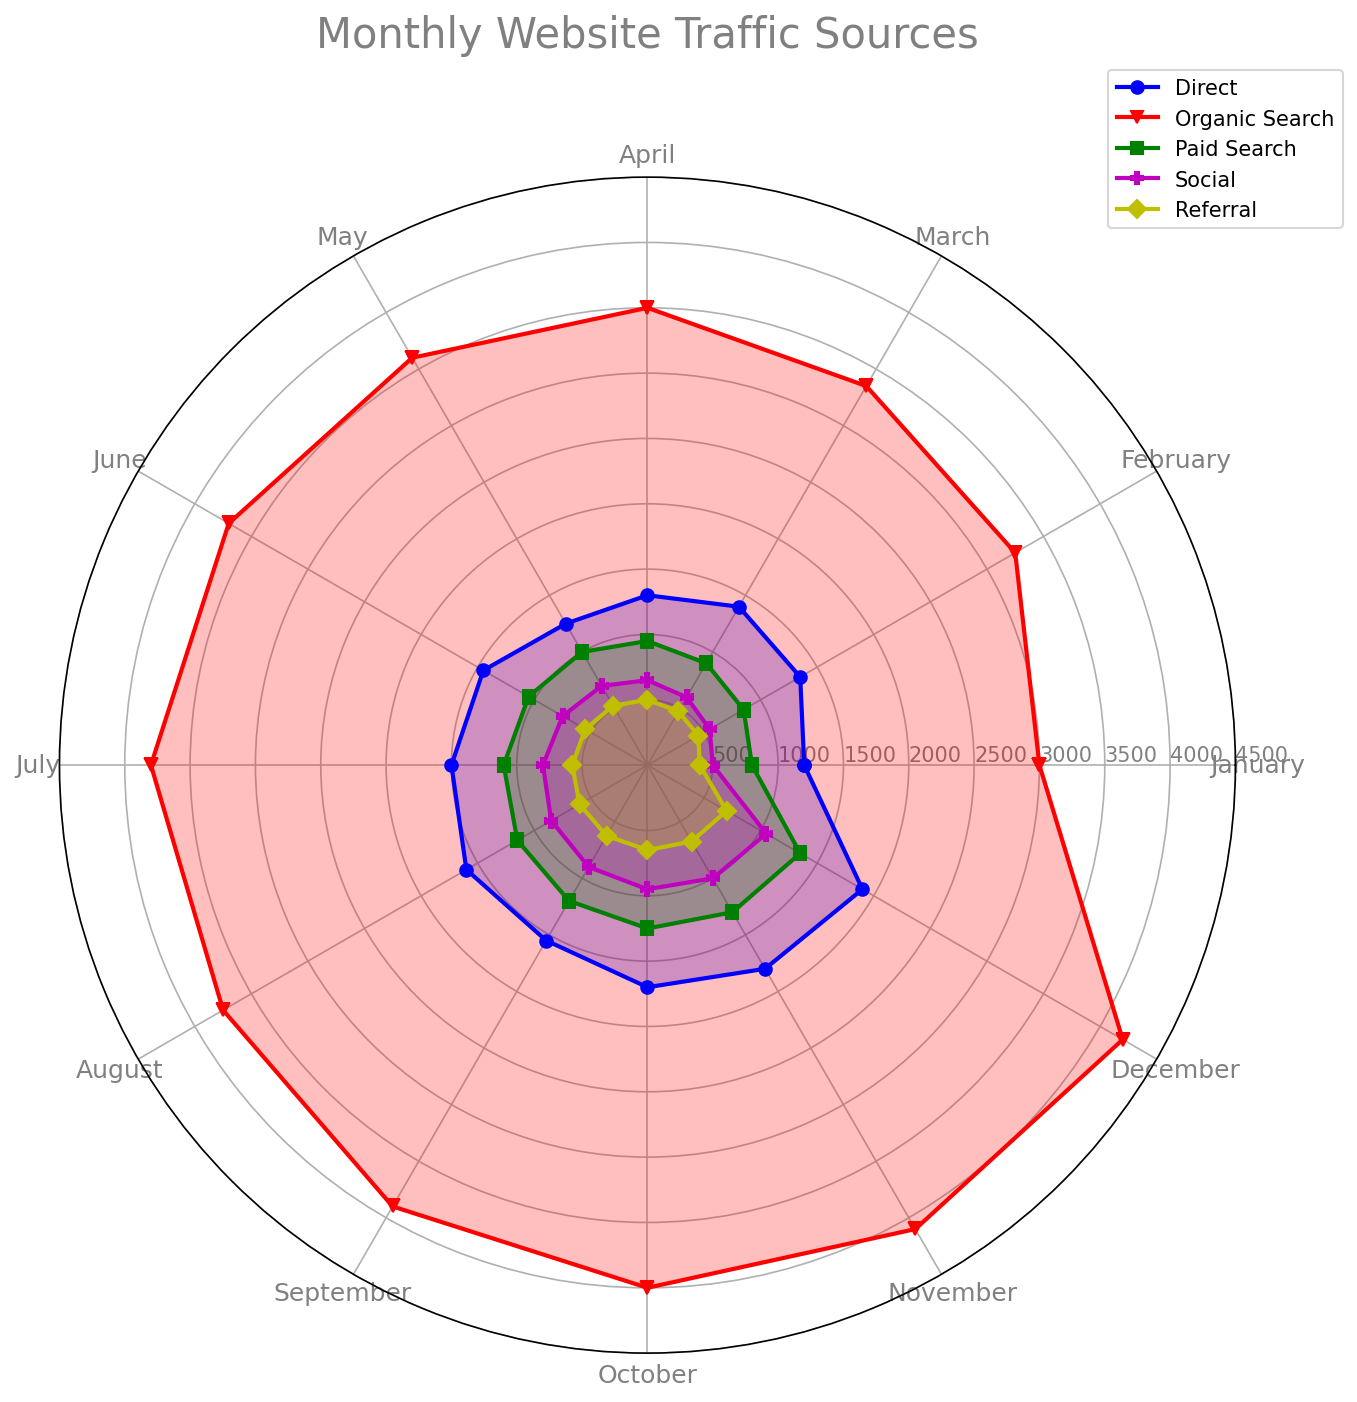what is the traffic source with the lowest overall values across months? By looking at the radar chart, we compare the plotted values for each traffic source. Referral has the smallest fill area, indicating its values are the lowest across the months.
Answer: Referral Which traffic source has the highest values in November? By checking the plotted values and their labels on the chart, Organic Search shows the highest value in November.
Answer: Organic Search what is the average monthly value of Social traffic? Add all monthly values of Social traffic and divide by 12: (500+550+600+650+700+750+800+850+900+950+1000+1050)/12 = 775
Answer: 775 How does Paid Search traffic in May compare to Direct traffic in May? In May, Paid Search traffic is 1000, while Direct traffic is 1250. Direct traffic is higher.
Answer: Direct is higher which traffic sources have an increasing trend over the months? By visually inspecting the shape of the plots for each source, Organic Search, Paid Search, Social, and Referral all show increasing trends as they move outwards through the months.
Answer: Organic Search, Paid Search, Social, Referral What is the difference between the highest and lowest traffic sources in December? In December, Organic Search has the highest value (4200), and Referral has the lowest (700). The difference is 4200 - 700 = 3500.
Answer: 3500 Is there any month where Social traffic surpasses Paid Search? By examining the plot, in none of the months does the Social traffic plot exceed the Paid Search plot.
Answer: No What is the sum of Direct and Referral traffic in August? In August, Direct traffic is 1600 and Referral is 600. Summing them gives 1600 + 600 = 2200.
Answer: 2200 Which traffic source has values exceeding 3000 in all months? By checking each traffic source's plot, only Organic Search has values that are greater than 3000 for all months.
Answer: Organic Search 